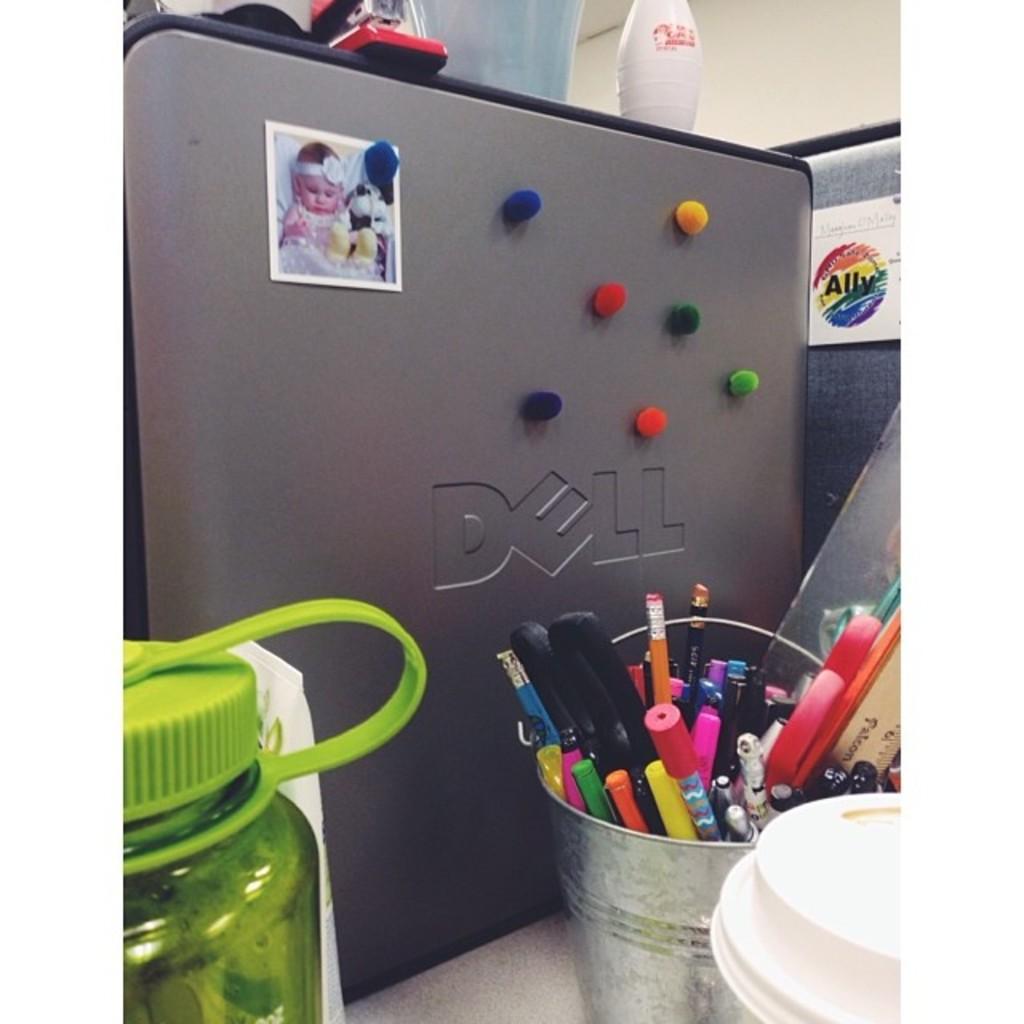What make of computer is this?
Provide a short and direct response. Dell. Does the sticker in the back say ally?
Offer a terse response. Yes. 